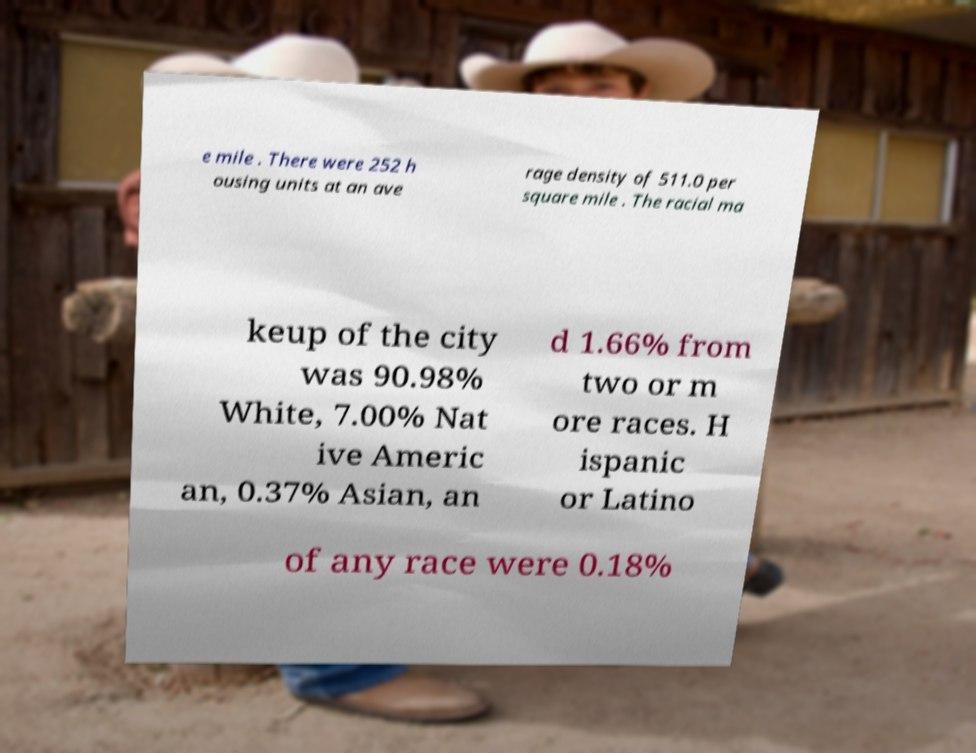I need the written content from this picture converted into text. Can you do that? e mile . There were 252 h ousing units at an ave rage density of 511.0 per square mile . The racial ma keup of the city was 90.98% White, 7.00% Nat ive Americ an, 0.37% Asian, an d 1.66% from two or m ore races. H ispanic or Latino of any race were 0.18% 